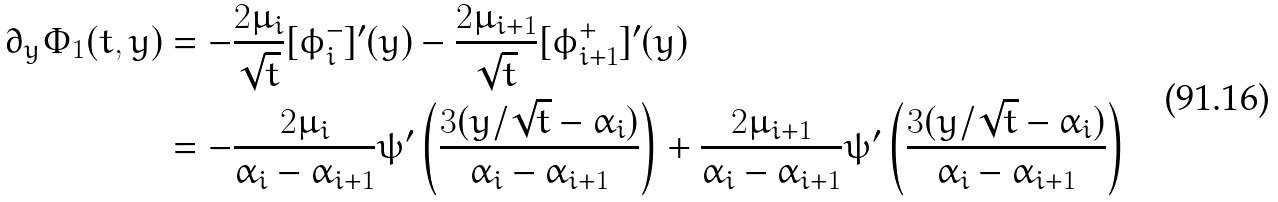Convert formula to latex. <formula><loc_0><loc_0><loc_500><loc_500>\partial _ { y } \Phi _ { 1 } ( t , y ) & = - \frac { 2 \mu _ { i } } { \sqrt { t } } [ \phi _ { i } ^ { - } ] ^ { \prime } ( y ) - \frac { 2 \mu _ { i + 1 } } { \sqrt { t } } [ \phi _ { i + 1 } ^ { + } ] ^ { \prime } ( y ) \\ & = - \frac { 2 \mu _ { i } } { \alpha _ { i } - \alpha _ { i + 1 } } \psi ^ { \prime } \left ( \frac { 3 ( y / \sqrt { t } - \alpha _ { i } ) } { \alpha _ { i } - \alpha _ { i + 1 } } \right ) + \frac { 2 \mu _ { i + 1 } } { \alpha _ { i } - \alpha _ { i + 1 } } \psi ^ { \prime } \left ( \frac { 3 ( y / \sqrt { t } - \alpha _ { i } ) } { \alpha _ { i } - \alpha _ { i + 1 } } \right )</formula> 